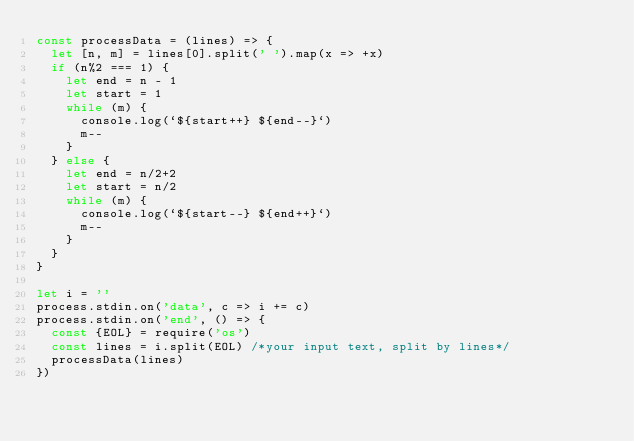Convert code to text. <code><loc_0><loc_0><loc_500><loc_500><_JavaScript_>const processData = (lines) => {
  let [n, m] = lines[0].split(' ').map(x => +x)
  if (n%2 === 1) {
    let end = n - 1
    let start = 1
    while (m) {
      console.log(`${start++} ${end--}`)
      m--
    }
  } else {
    let end = n/2+2
    let start = n/2
    while (m) {
      console.log(`${start--} ${end++}`)
      m--
    }
  }
}

let i = ''
process.stdin.on('data', c => i += c)
process.stdin.on('end', () => {
  const {EOL} = require('os')
  const lines = i.split(EOL) /*your input text, split by lines*/
  processData(lines)
})
</code> 